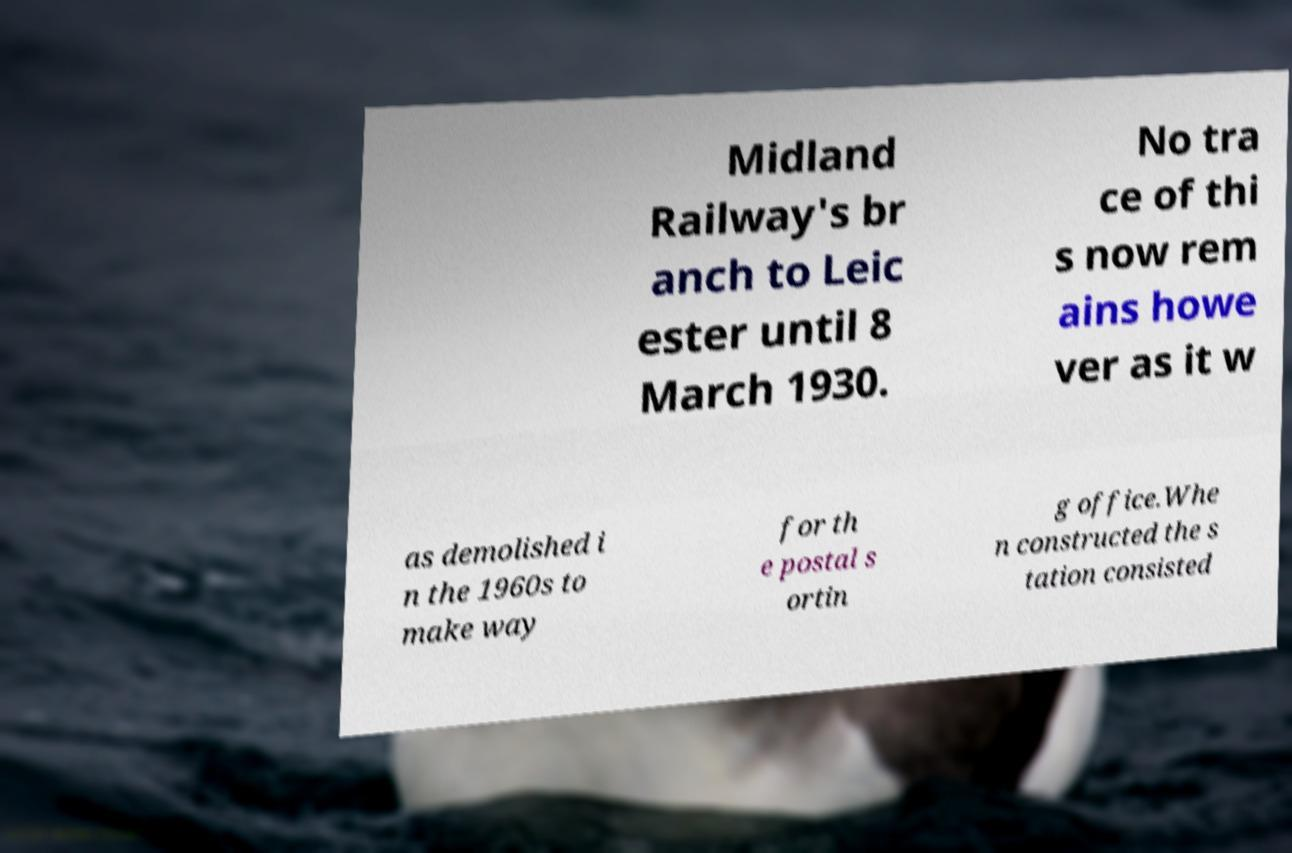For documentation purposes, I need the text within this image transcribed. Could you provide that? Midland Railway's br anch to Leic ester until 8 March 1930. No tra ce of thi s now rem ains howe ver as it w as demolished i n the 1960s to make way for th e postal s ortin g office.Whe n constructed the s tation consisted 